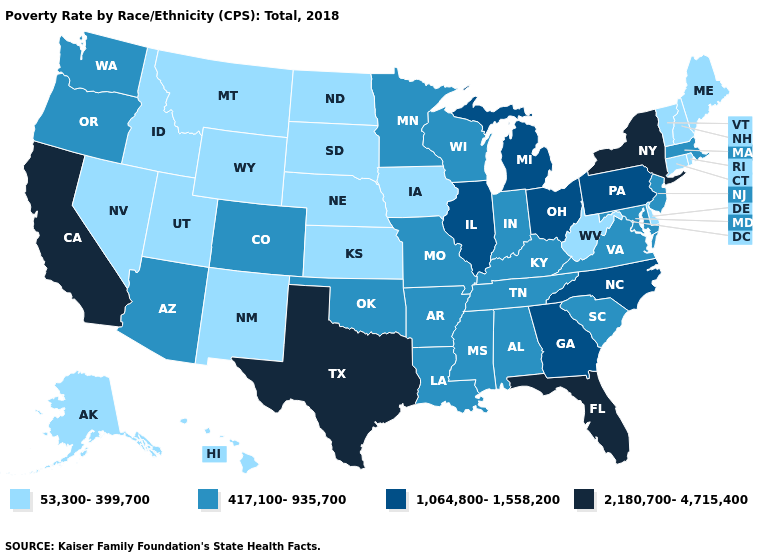What is the value of Virginia?
Give a very brief answer. 417,100-935,700. What is the value of South Carolina?
Give a very brief answer. 417,100-935,700. Name the states that have a value in the range 417,100-935,700?
Concise answer only. Alabama, Arizona, Arkansas, Colorado, Indiana, Kentucky, Louisiana, Maryland, Massachusetts, Minnesota, Mississippi, Missouri, New Jersey, Oklahoma, Oregon, South Carolina, Tennessee, Virginia, Washington, Wisconsin. What is the value of Ohio?
Be succinct. 1,064,800-1,558,200. Name the states that have a value in the range 1,064,800-1,558,200?
Quick response, please. Georgia, Illinois, Michigan, North Carolina, Ohio, Pennsylvania. Name the states that have a value in the range 2,180,700-4,715,400?
Answer briefly. California, Florida, New York, Texas. What is the value of Oklahoma?
Write a very short answer. 417,100-935,700. Does Oregon have the highest value in the West?
Give a very brief answer. No. Name the states that have a value in the range 53,300-399,700?
Quick response, please. Alaska, Connecticut, Delaware, Hawaii, Idaho, Iowa, Kansas, Maine, Montana, Nebraska, Nevada, New Hampshire, New Mexico, North Dakota, Rhode Island, South Dakota, Utah, Vermont, West Virginia, Wyoming. What is the highest value in the USA?
Quick response, please. 2,180,700-4,715,400. Name the states that have a value in the range 2,180,700-4,715,400?
Be succinct. California, Florida, New York, Texas. Does Ohio have a higher value than Maine?
Quick response, please. Yes. Name the states that have a value in the range 53,300-399,700?
Write a very short answer. Alaska, Connecticut, Delaware, Hawaii, Idaho, Iowa, Kansas, Maine, Montana, Nebraska, Nevada, New Hampshire, New Mexico, North Dakota, Rhode Island, South Dakota, Utah, Vermont, West Virginia, Wyoming. Does Utah have the same value as Pennsylvania?
Be succinct. No. Does Nebraska have the same value as Maryland?
Concise answer only. No. 